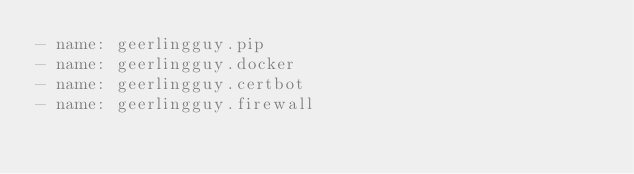Convert code to text. <code><loc_0><loc_0><loc_500><loc_500><_YAML_>- name: geerlingguy.pip
- name: geerlingguy.docker
- name: geerlingguy.certbot
- name: geerlingguy.firewall</code> 